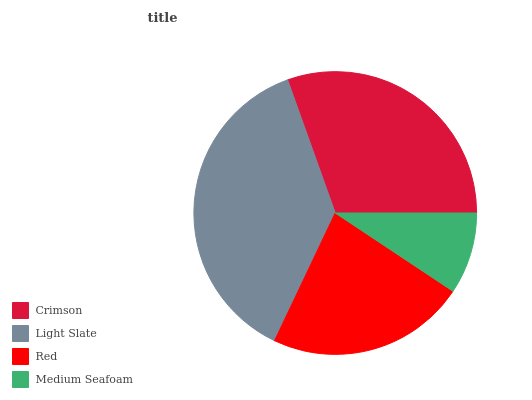Is Medium Seafoam the minimum?
Answer yes or no. Yes. Is Light Slate the maximum?
Answer yes or no. Yes. Is Red the minimum?
Answer yes or no. No. Is Red the maximum?
Answer yes or no. No. Is Light Slate greater than Red?
Answer yes or no. Yes. Is Red less than Light Slate?
Answer yes or no. Yes. Is Red greater than Light Slate?
Answer yes or no. No. Is Light Slate less than Red?
Answer yes or no. No. Is Crimson the high median?
Answer yes or no. Yes. Is Red the low median?
Answer yes or no. Yes. Is Light Slate the high median?
Answer yes or no. No. Is Medium Seafoam the low median?
Answer yes or no. No. 